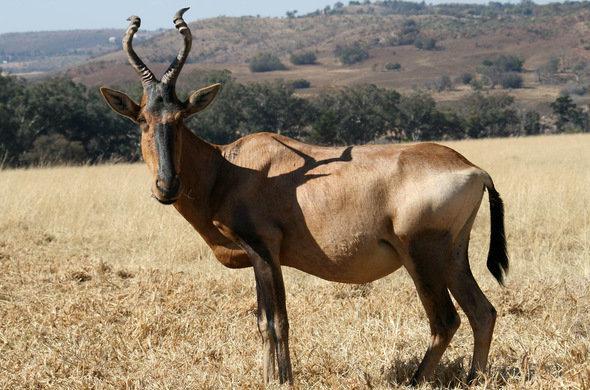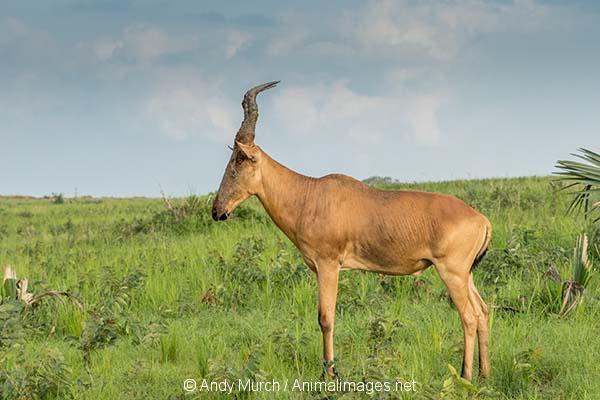The first image is the image on the left, the second image is the image on the right. Given the left and right images, does the statement "An image shows one horned animal with body in profile and face turned toward camera." hold true? Answer yes or no. Yes. The first image is the image on the left, the second image is the image on the right. Given the left and right images, does the statement "Each image contains exactly one antelope facing in the same direction." hold true? Answer yes or no. Yes. 